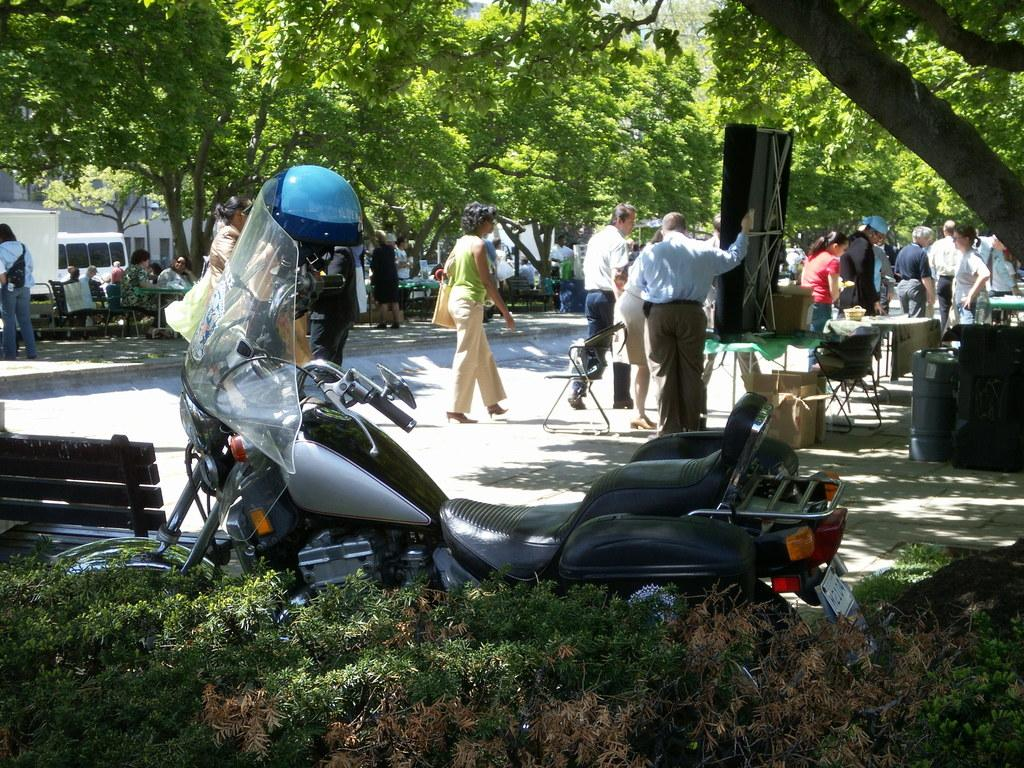What type of vehicle is in the image? There is a motorcycle in the image. What type of seating is available in the image? There is a bench and chairs in the image. Are there any living beings in the image? Yes, there are people present in the image. What type of vegetation is in the image? There are plants and trees in the image. What structures can be seen in the background of the image? There are buildings visible behind the trees in the image. What type of family behavior is depicted in the image? There is no family or behavior depicted in the image; it features a motorcycle, a bench, chairs, people, plants, trees, and buildings. What type of arch can be seen in the image? There is no arch present in the image. 